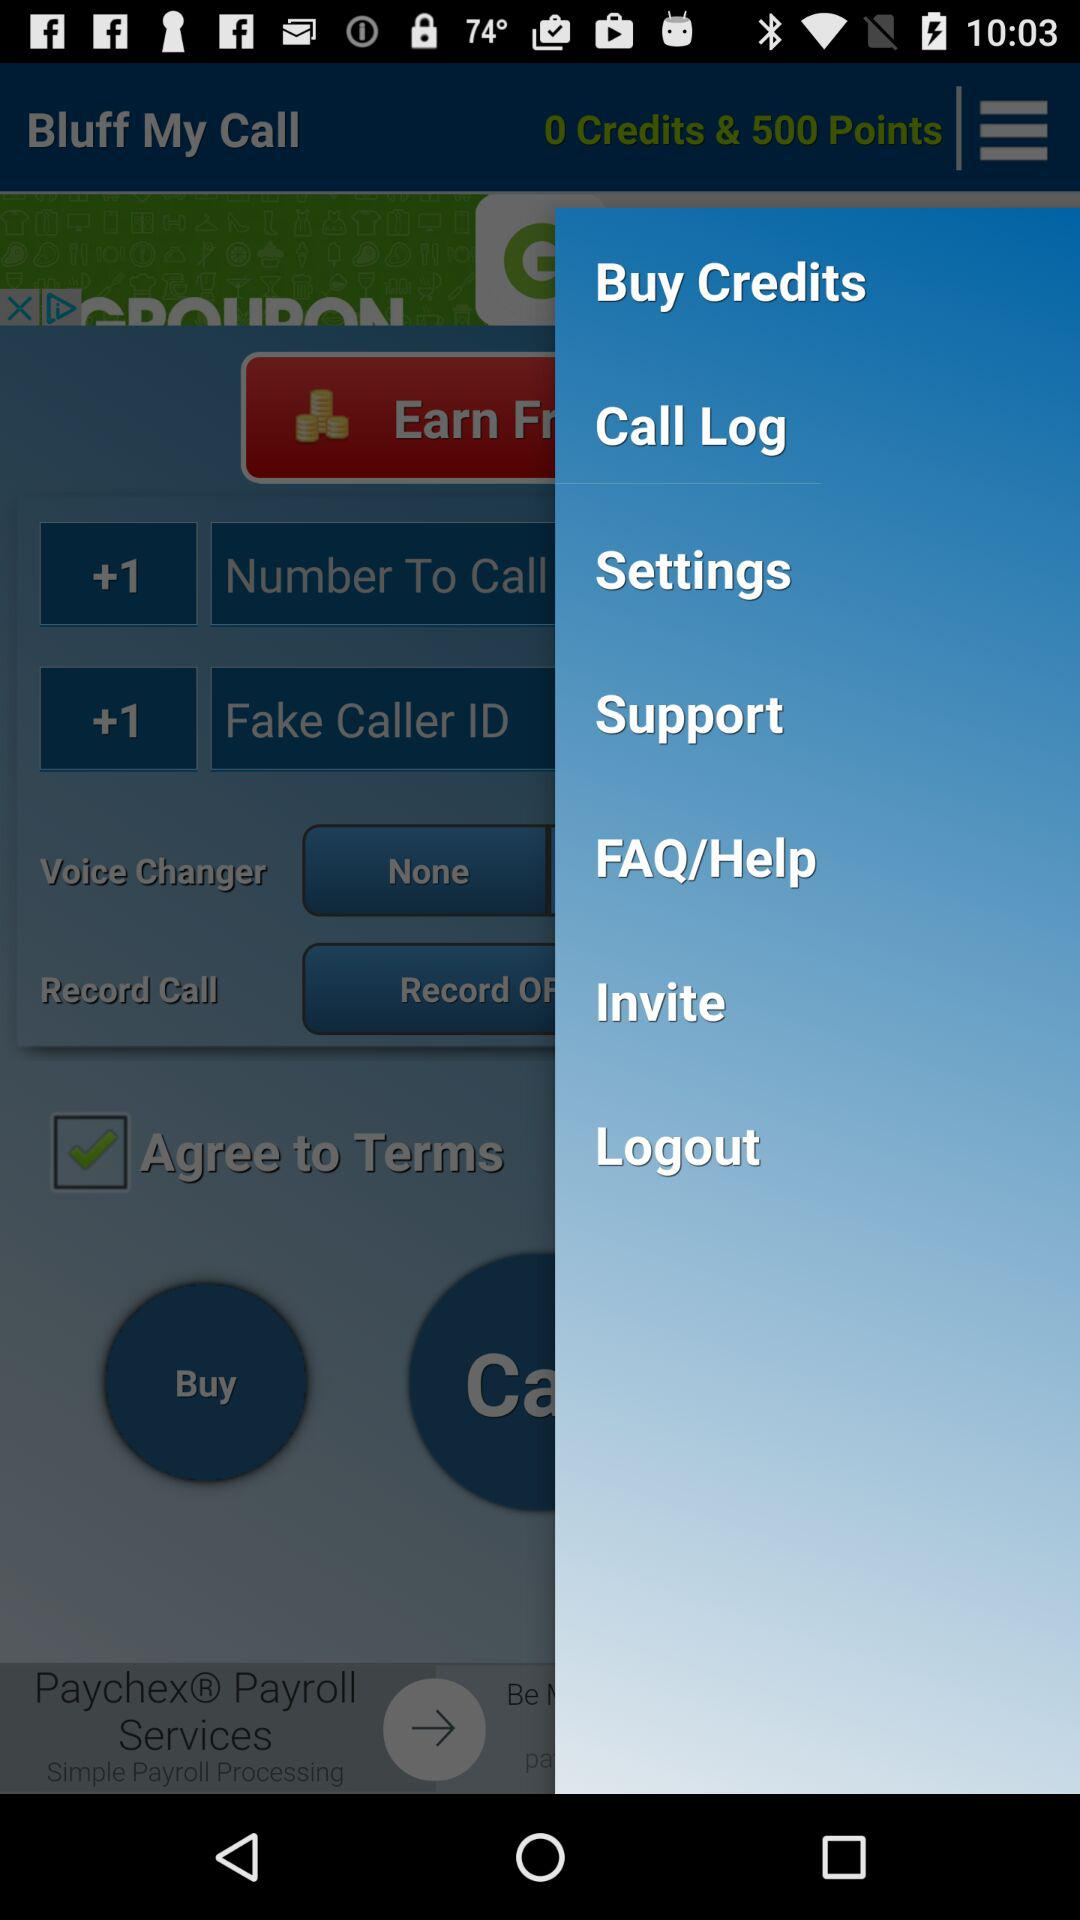How many points are shown on the screen? There are 500 points shown on the screen. 